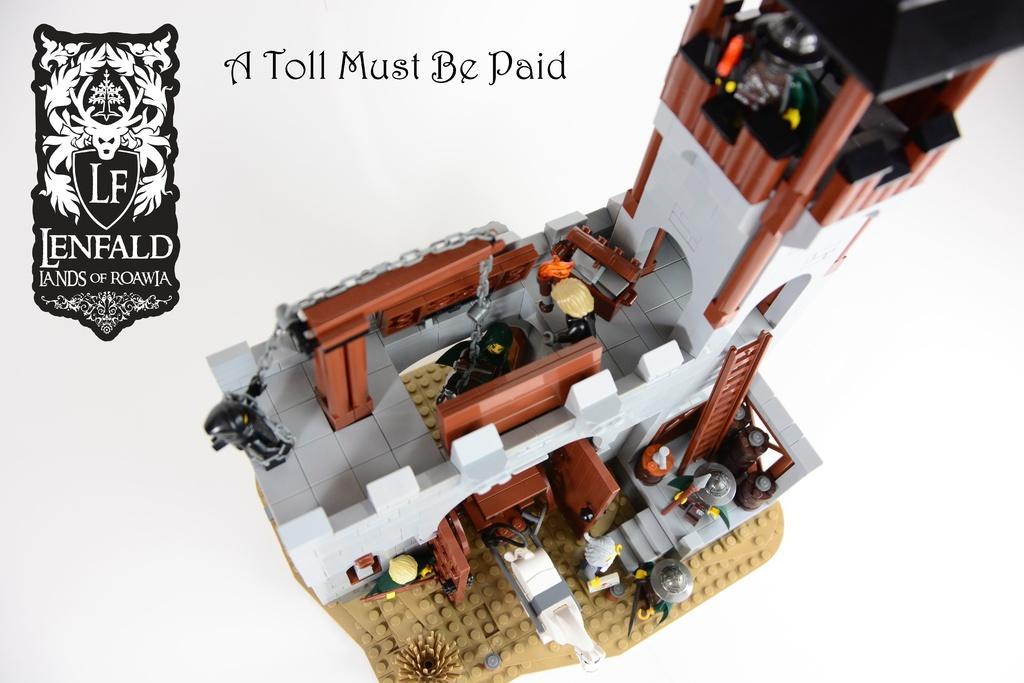Can you describe this image briefly? In the picture I can see toys in shape of a building. I can also see a logo and something written on the image. The background of the image is white in color. 